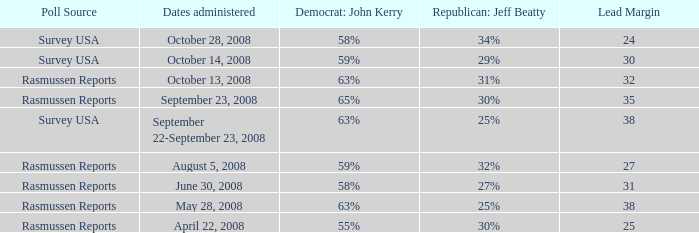Could you parse the entire table? {'header': ['Poll Source', 'Dates administered', 'Democrat: John Kerry', 'Republican: Jeff Beatty', 'Lead Margin'], 'rows': [['Survey USA', 'October 28, 2008', '58%', '34%', '24'], ['Survey USA', 'October 14, 2008', '59%', '29%', '30'], ['Rasmussen Reports', 'October 13, 2008', '63%', '31%', '32'], ['Rasmussen Reports', 'September 23, 2008', '65%', '30%', '35'], ['Survey USA', 'September 22-September 23, 2008', '63%', '25%', '38'], ['Rasmussen Reports', 'August 5, 2008', '59%', '32%', '27'], ['Rasmussen Reports', 'June 30, 2008', '58%', '27%', '31'], ['Rasmussen Reports', 'May 28, 2008', '63%', '25%', '38'], ['Rasmussen Reports', 'April 22, 2008', '55%', '30%', '25']]} What are the dates where democrat john kerry is 63% and poll source is rasmussen reports? October 13, 2008, May 28, 2008. 